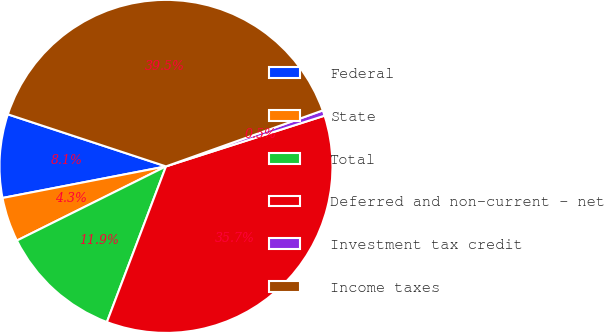Convert chart to OTSL. <chart><loc_0><loc_0><loc_500><loc_500><pie_chart><fcel>Federal<fcel>State<fcel>Total<fcel>Deferred and non-current - net<fcel>Investment tax credit<fcel>Income taxes<nl><fcel>8.1%<fcel>4.31%<fcel>11.88%<fcel>35.7%<fcel>0.53%<fcel>39.48%<nl></chart> 